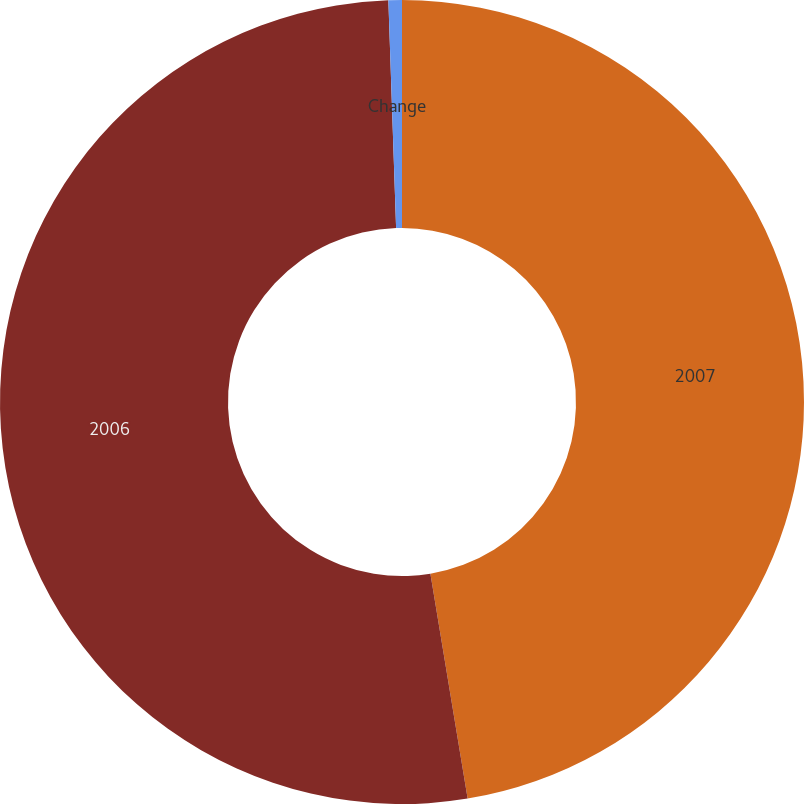Convert chart. <chart><loc_0><loc_0><loc_500><loc_500><pie_chart><fcel>2007<fcel>2006<fcel>Change<nl><fcel>47.39%<fcel>52.07%<fcel>0.54%<nl></chart> 